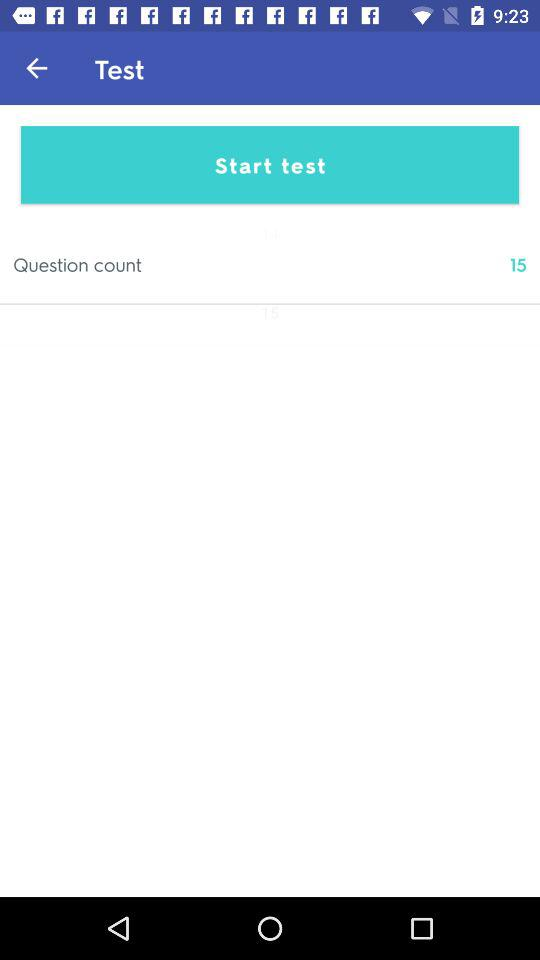What is the question count? The question count is 15. 